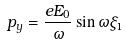<formula> <loc_0><loc_0><loc_500><loc_500>p _ { y } = \frac { e E _ { 0 } } { \omega } \sin \omega \xi _ { 1 }</formula> 